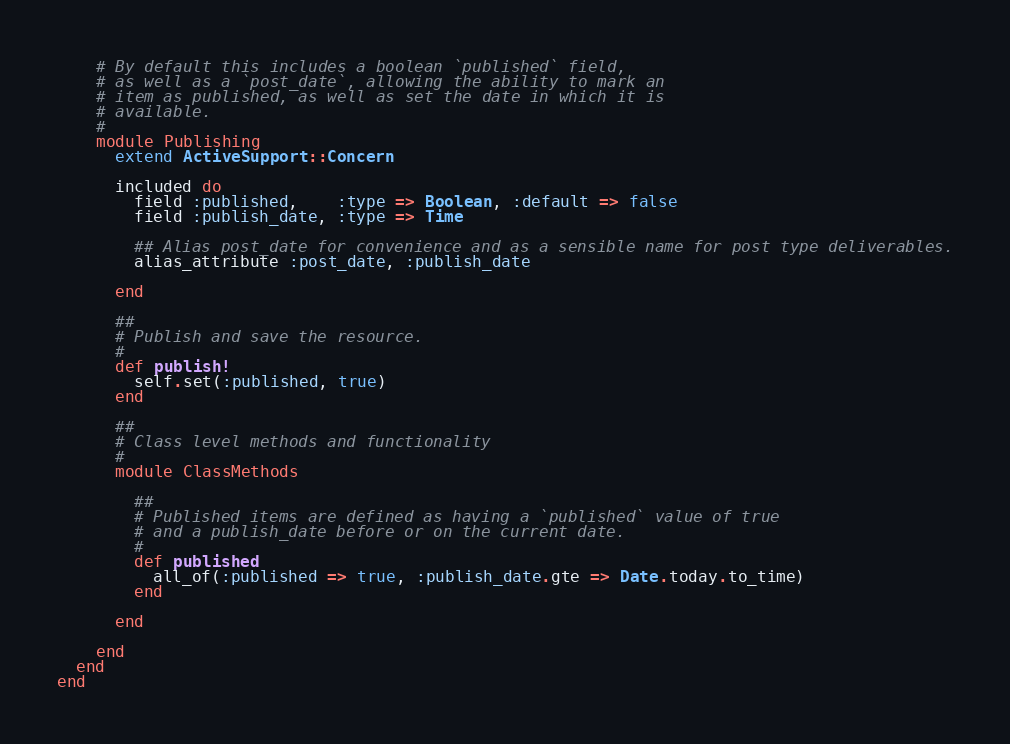<code> <loc_0><loc_0><loc_500><loc_500><_Ruby_>    # By default this includes a boolean `published` field, 
    # as well as a `post_date`, allowing the ability to mark an
    # item as published, as well as set the date in which it is 
    # available.
    # 
    module Publishing
      extend ActiveSupport::Concern
      
      included do
        field :published,    :type => Boolean, :default => false
        field :publish_date, :type => Time

        ## Alias post_date for convenience and as a sensible name for post type deliverables.
        alias_attribute :post_date, :publish_date
        
      end
      
      ##
      # Publish and save the resource.
      # 
      def publish!
        self.set(:published, true)
      end
      
      ##
      # Class level methods and functionality
      # 
      module ClassMethods
        
        ##
        # Published items are defined as having a `published` value of true
        # and a publish_date before or on the current date.
        # 
        def published
          all_of(:published => true, :publish_date.gte => Date.today.to_time)
        end
        
      end
      
    end
  end
end</code> 